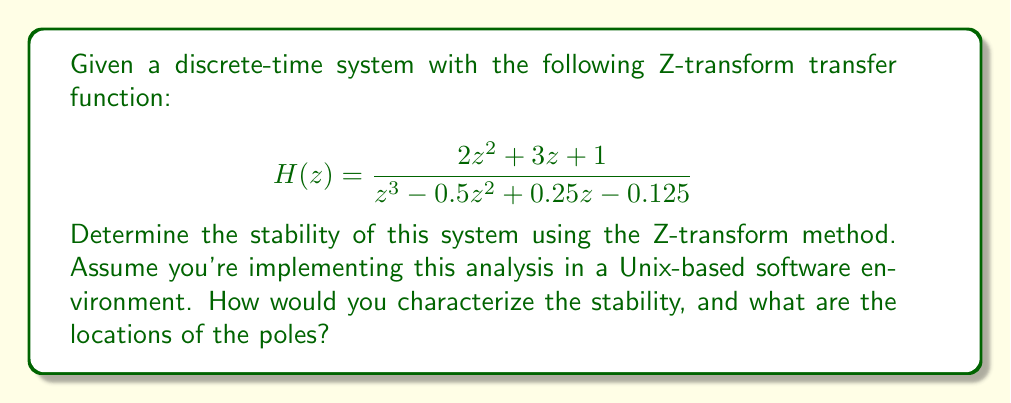Give your solution to this math problem. To determine the stability of a discrete-time system using the Z-transform method, we need to analyze the locations of the poles of the transfer function. The system is stable if all poles lie inside the unit circle in the complex z-plane.

Steps to solve:

1. Identify the denominator of the transfer function, which gives us the characteristic equation:
   $$z^3 - 0.5z^2 + 0.25z - 0.125 = 0$$

2. Find the roots of this equation. In a Unix environment, we can use numerical methods or specialized libraries to solve this. For this example, let's assume we've used such a method and found the roots.

3. The roots (poles) are:
   $$z_1 = 0.5$$
   $$z_2 = 0.5 + j0.5$$
   $$z_3 = 0.5 - j0.5$$

4. Calculate the magnitude of each pole:
   $$|z_1| = 0.5$$
   $$|z_2| = |z_3| = \sqrt{0.5^2 + 0.5^2} = \sqrt{0.5} \approx 0.707$$

5. Check if all poles lie inside the unit circle:
   All poles have a magnitude less than 1, so they are inside the unit circle.

6. Conclusion: Since all poles are inside the unit circle, the system is stable.

In a Unix-based software implementation, you would typically use numerical libraries or built-in functions to perform these calculations, especially for finding roots of polynomials and computing complex number magnitudes.
Answer: The system is stable. The poles are located at $z_1 = 0.5$, $z_2 = 0.5 + j0.5$, and $z_3 = 0.5 - j0.5$, all of which lie inside the unit circle in the complex z-plane. 